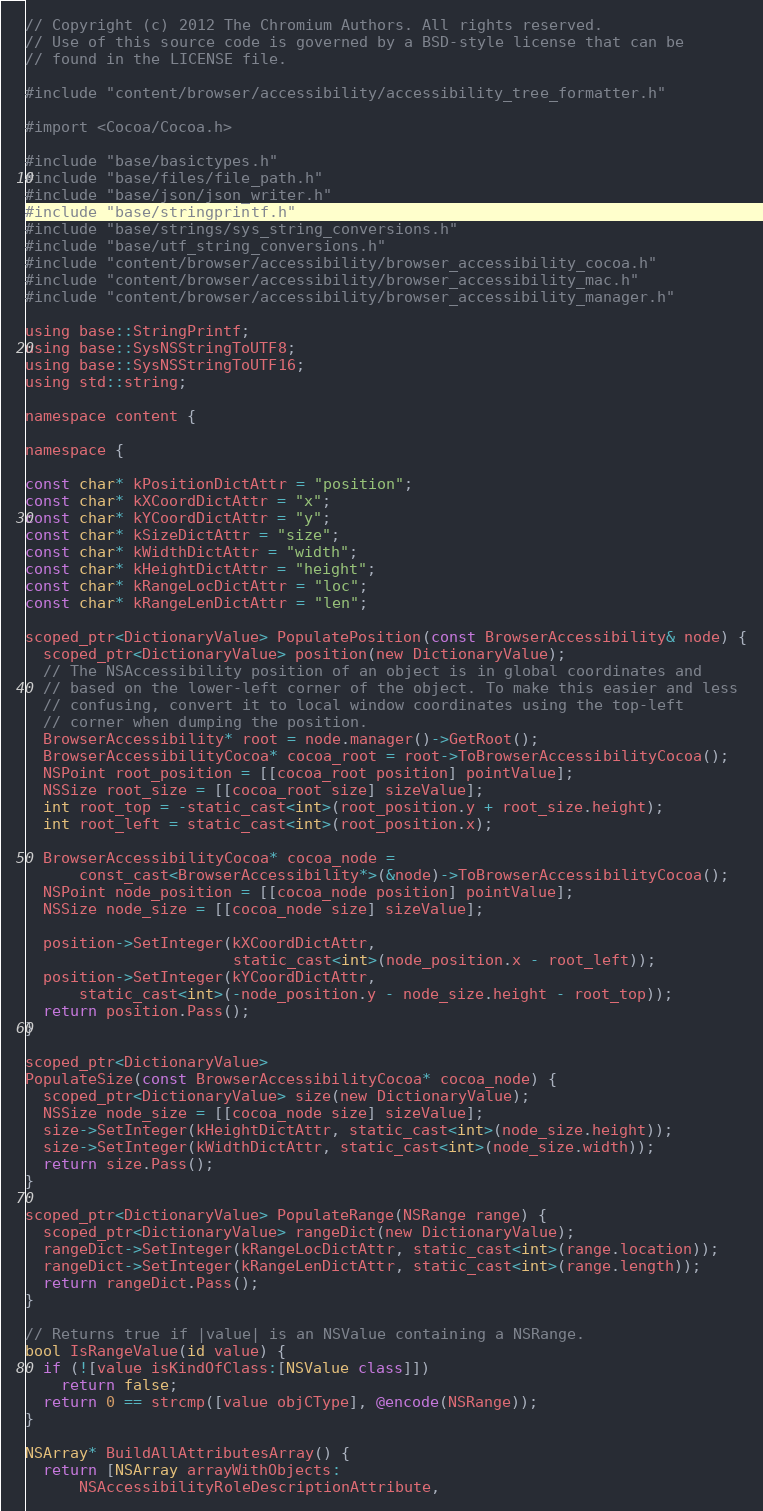<code> <loc_0><loc_0><loc_500><loc_500><_ObjectiveC_>// Copyright (c) 2012 The Chromium Authors. All rights reserved.
// Use of this source code is governed by a BSD-style license that can be
// found in the LICENSE file.

#include "content/browser/accessibility/accessibility_tree_formatter.h"

#import <Cocoa/Cocoa.h>

#include "base/basictypes.h"
#include "base/files/file_path.h"
#include "base/json/json_writer.h"
#include "base/stringprintf.h"
#include "base/strings/sys_string_conversions.h"
#include "base/utf_string_conversions.h"
#include "content/browser/accessibility/browser_accessibility_cocoa.h"
#include "content/browser/accessibility/browser_accessibility_mac.h"
#include "content/browser/accessibility/browser_accessibility_manager.h"

using base::StringPrintf;
using base::SysNSStringToUTF8;
using base::SysNSStringToUTF16;
using std::string;

namespace content {

namespace {

const char* kPositionDictAttr = "position";
const char* kXCoordDictAttr = "x";
const char* kYCoordDictAttr = "y";
const char* kSizeDictAttr = "size";
const char* kWidthDictAttr = "width";
const char* kHeightDictAttr = "height";
const char* kRangeLocDictAttr = "loc";
const char* kRangeLenDictAttr = "len";

scoped_ptr<DictionaryValue> PopulatePosition(const BrowserAccessibility& node) {
  scoped_ptr<DictionaryValue> position(new DictionaryValue);
  // The NSAccessibility position of an object is in global coordinates and
  // based on the lower-left corner of the object. To make this easier and less
  // confusing, convert it to local window coordinates using the top-left
  // corner when dumping the position.
  BrowserAccessibility* root = node.manager()->GetRoot();
  BrowserAccessibilityCocoa* cocoa_root = root->ToBrowserAccessibilityCocoa();
  NSPoint root_position = [[cocoa_root position] pointValue];
  NSSize root_size = [[cocoa_root size] sizeValue];
  int root_top = -static_cast<int>(root_position.y + root_size.height);
  int root_left = static_cast<int>(root_position.x);

  BrowserAccessibilityCocoa* cocoa_node =
      const_cast<BrowserAccessibility*>(&node)->ToBrowserAccessibilityCocoa();
  NSPoint node_position = [[cocoa_node position] pointValue];
  NSSize node_size = [[cocoa_node size] sizeValue];

  position->SetInteger(kXCoordDictAttr,
                       static_cast<int>(node_position.x - root_left));
  position->SetInteger(kYCoordDictAttr,
      static_cast<int>(-node_position.y - node_size.height - root_top));
  return position.Pass();
}

scoped_ptr<DictionaryValue>
PopulateSize(const BrowserAccessibilityCocoa* cocoa_node) {
  scoped_ptr<DictionaryValue> size(new DictionaryValue);
  NSSize node_size = [[cocoa_node size] sizeValue];
  size->SetInteger(kHeightDictAttr, static_cast<int>(node_size.height));
  size->SetInteger(kWidthDictAttr, static_cast<int>(node_size.width));
  return size.Pass();
}

scoped_ptr<DictionaryValue> PopulateRange(NSRange range) {
  scoped_ptr<DictionaryValue> rangeDict(new DictionaryValue);
  rangeDict->SetInteger(kRangeLocDictAttr, static_cast<int>(range.location));
  rangeDict->SetInteger(kRangeLenDictAttr, static_cast<int>(range.length));
  return rangeDict.Pass();
}

// Returns true if |value| is an NSValue containing a NSRange.
bool IsRangeValue(id value) {
  if (![value isKindOfClass:[NSValue class]])
    return false;
  return 0 == strcmp([value objCType], @encode(NSRange));
}

NSArray* BuildAllAttributesArray() {
  return [NSArray arrayWithObjects:
      NSAccessibilityRoleDescriptionAttribute,</code> 